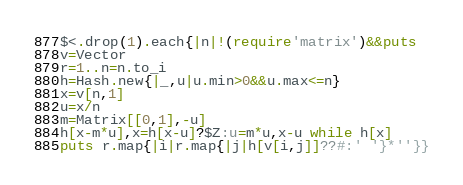<code> <loc_0><loc_0><loc_500><loc_500><_Ruby_>$<.drop(1).each{|n|!(require'matrix')&&puts
v=Vector
r=1..n=n.to_i
h=Hash.new{|_,u|u.min>0&&u.max<=n}
x=v[n,1]
u=x/n
m=Matrix[[0,1],-u]
h[x-m*u],x=h[x-u]?$Z:u=m*u,x-u while h[x]
puts r.map{|i|r.map{|j|h[v[i,j]]??#:' '}*''}}

</code> 